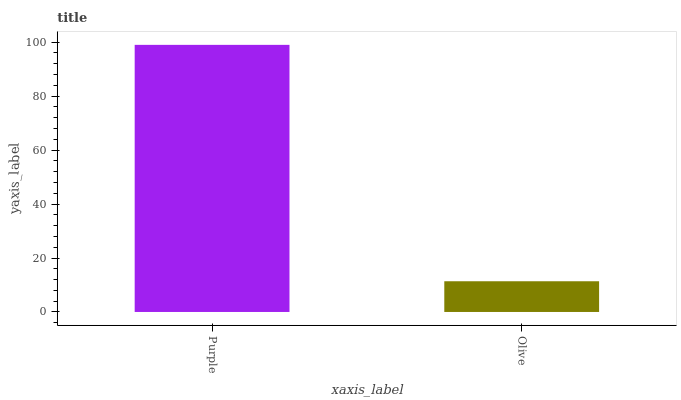Is Olive the minimum?
Answer yes or no. Yes. Is Purple the maximum?
Answer yes or no. Yes. Is Olive the maximum?
Answer yes or no. No. Is Purple greater than Olive?
Answer yes or no. Yes. Is Olive less than Purple?
Answer yes or no. Yes. Is Olive greater than Purple?
Answer yes or no. No. Is Purple less than Olive?
Answer yes or no. No. Is Purple the high median?
Answer yes or no. Yes. Is Olive the low median?
Answer yes or no. Yes. Is Olive the high median?
Answer yes or no. No. Is Purple the low median?
Answer yes or no. No. 